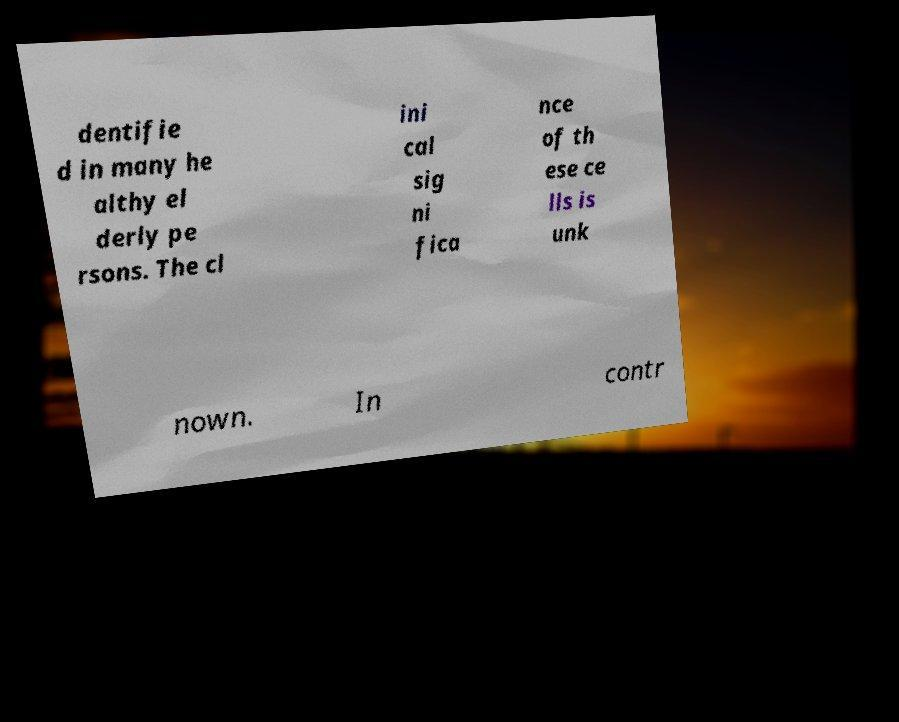Please read and relay the text visible in this image. What does it say? dentifie d in many he althy el derly pe rsons. The cl ini cal sig ni fica nce of th ese ce lls is unk nown. In contr 